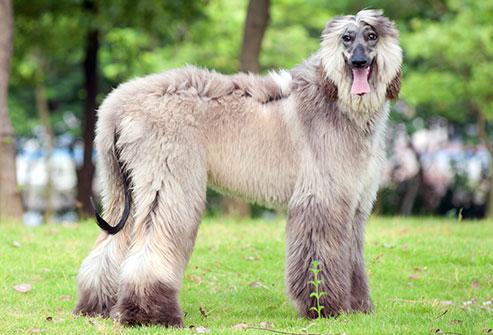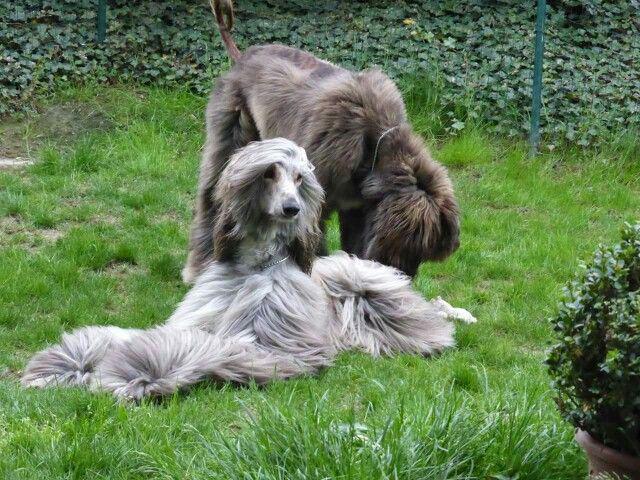The first image is the image on the left, the second image is the image on the right. Assess this claim about the two images: "There is a dog running in one of the images.". Correct or not? Answer yes or no. No. The first image is the image on the left, the second image is the image on the right. Evaluate the accuracy of this statement regarding the images: "One image shows a hound bounding across the grass.". Is it true? Answer yes or no. No. 